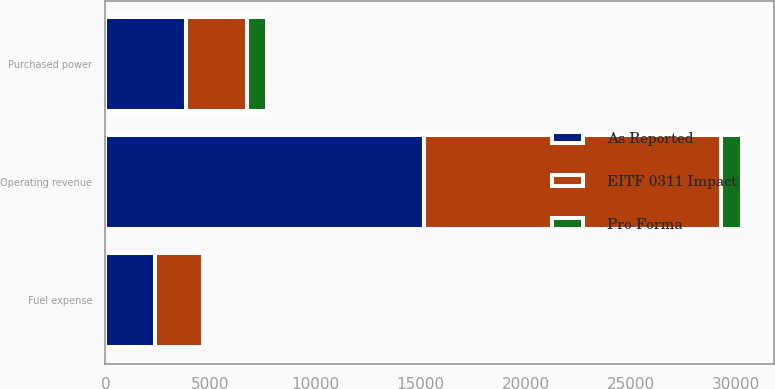Convert chart. <chart><loc_0><loc_0><loc_500><loc_500><stacked_bar_chart><ecel><fcel>Operating revenue<fcel>Purchased power<fcel>Fuel expense<nl><fcel>As Reported<fcel>15148<fcel>3841<fcel>2353<nl><fcel>Pro Forma<fcel>996<fcel>943<fcel>53<nl><fcel>EITF 0311 Impact<fcel>14152<fcel>2898<fcel>2300<nl></chart> 